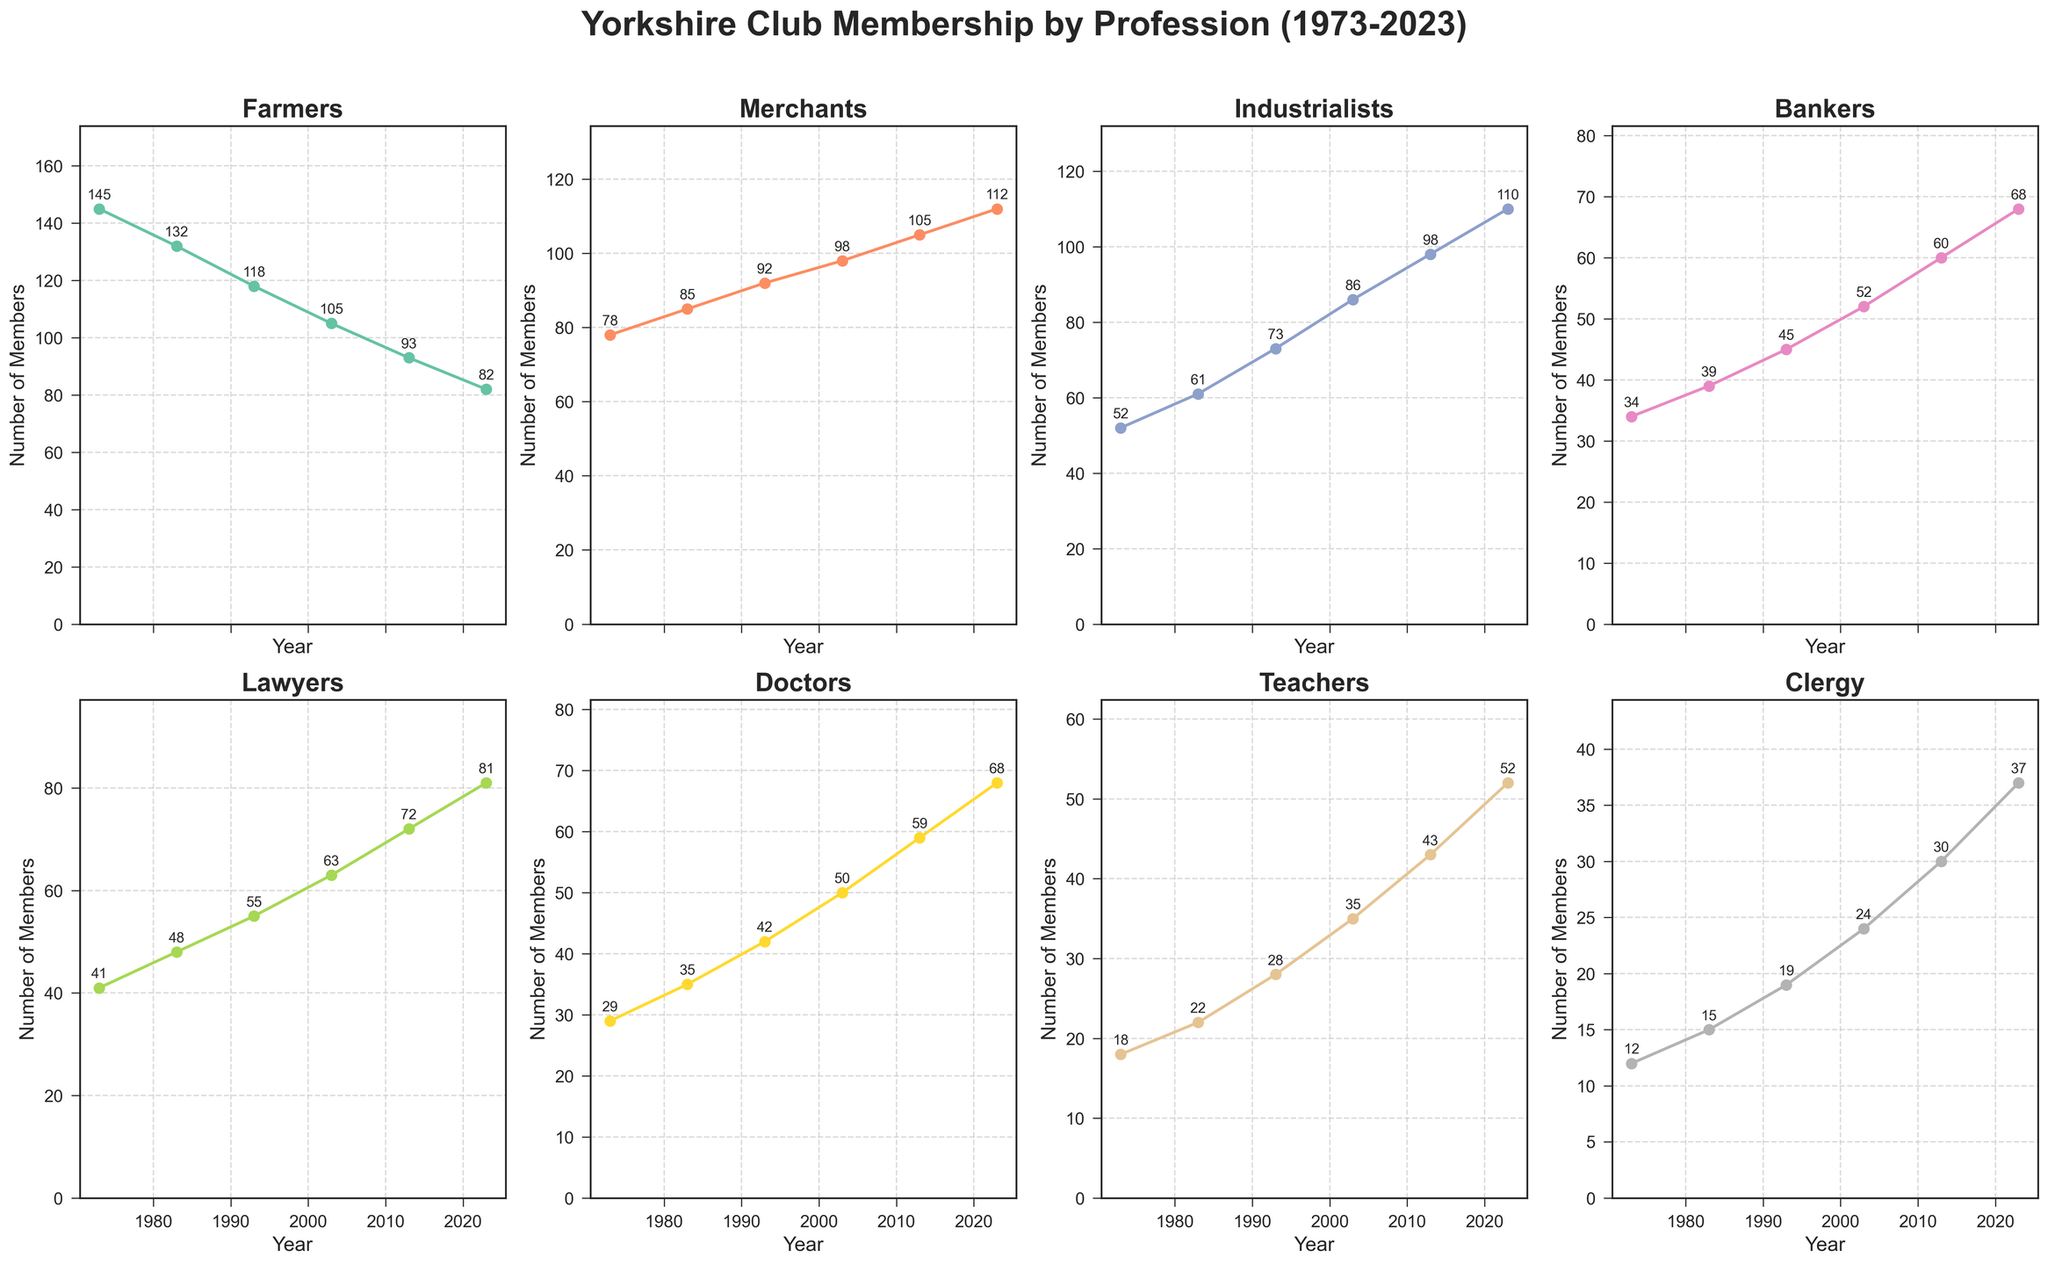What is the overall trend of membership for Farmers? The line for Farmers is shown decreasing from 145 members in 1973 to 82 members in 2023. Each point along the line represents a data point for every decade, and all points move generally downwards.
Answer: Decreasing Which profession had the most members in 2023? In 2023, the highest point among all subplots is for Industrialists, with 110 members. By comparing the final point (2023) on each profession's subplot, Industrialists have the highest value.
Answer: Industrialists How many professions had an increase in membership from 1973 to 2023? By examining the starting and ending points for all professions: Farmers (decrease), Merchants (increase), Industrialists (increase), Bankers (increase), Lawyers (increase), Doctors (increase), Teachers (increase), Clergy (increase), the count of professions with an increasing number of members is 7.
Answer: 7 What's the difference in membership between Bankers and Lawyers in 2003? In the subplots, we find the 2003 values for Bankers (52 members) and Lawyers (63 members). The difference is obtained by subtracting the Bankers' count from the Lawyers' count: 63 - 52.
Answer: 11 Which profession had the smallest change in membership over the 50 years? The subplot for Clergy shows a change from 12 members in 1973 to 37 members in 2023. Among the professions, comparing the changes: Farmers (63), Merchants (34), Industrialists (58), Bankers (34), Lawyers (40), Doctors (39), Teachers (34), Clergy's change is 25. Clergy has the smallest numeric change in membership.
Answer: Clergy In which decade did Lawyers see the greatest increase in members? Looking at the Lawyers subplot: 1973 (41), 1983 (48), 1993 (55), 2003 (63), 2013 (72), 2023 (81). The differences (increases) are: 7 (between '73-'83), 7, 8, 9, 9. The greatest single increase happened between 2003 and 2013.
Answer: 2003 to 2013 Compare the membership trends of Doctors and Teachers from 1973 to 2023. The subplot for Doctors shows a rise from 29 in 1973 to 68 in 2023. For Teachers, it rises from 18 in 1973 to 52 in 2023. Both have an increasing trend, while Doctors show a more rapid increase and a higher final count. Analyzing each data point's upward trajectory validates the increase for both professions, with Doctors ascending steeper.
Answer: Both increased, Doctors more rapidly Which two professions had the closest number of members in 1983? In 1983, the profession counts are: Farmers (132), Merchants (85), Industrialists (61), Bankers (39), Lawyers (48), Doctors (35), Teachers (22), Clergy (15). The closest values are Teachers (22) and Clergy (15), differing by only 7.
Answer: Teachers and Clergy What is the average membership of Industrialists across all years? Summing the membership numbers for Industrialists (1973: 52, 1983: 61, 1993: 73, 2003: 86, 2013: 98, 2023: 110) results in a total of 480. There are 6 data points, so the average is 480/6.
Answer: 80 How did the membership of Merchants change from 1973 to 1993? The membership for Merchants in 1973 is 78 and increases to 92 in 1993. The change can be found by subtracting 78 from 92.
Answer: 14 